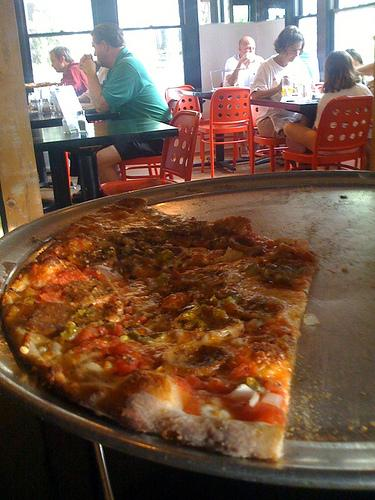What category of pizza would this fall into? Please explain your reasoning. vegetarian. The pizza does not have meat on it. 